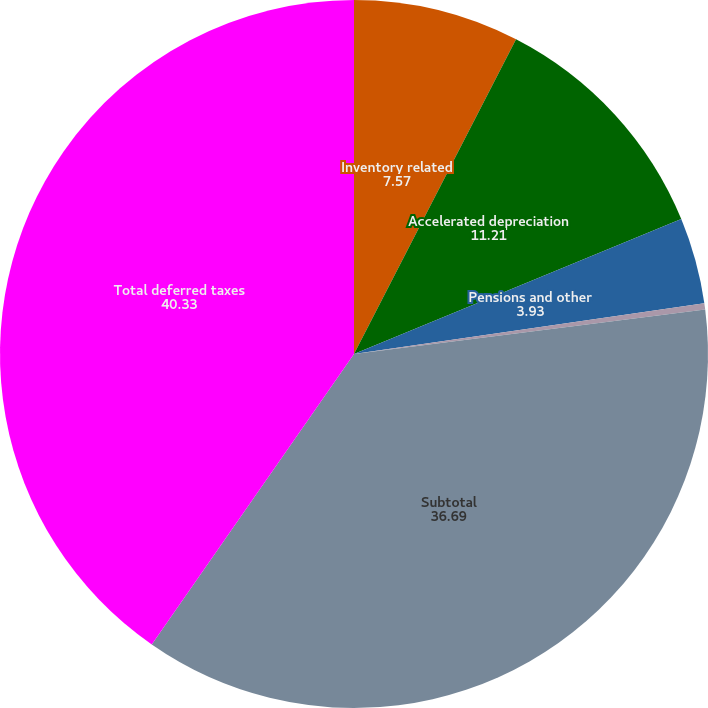<chart> <loc_0><loc_0><loc_500><loc_500><pie_chart><fcel>Inventory related<fcel>Accelerated depreciation<fcel>Pensions and other<fcel>Other<fcel>Subtotal<fcel>Total deferred taxes<nl><fcel>7.57%<fcel>11.21%<fcel>3.93%<fcel>0.29%<fcel>36.69%<fcel>40.33%<nl></chart> 